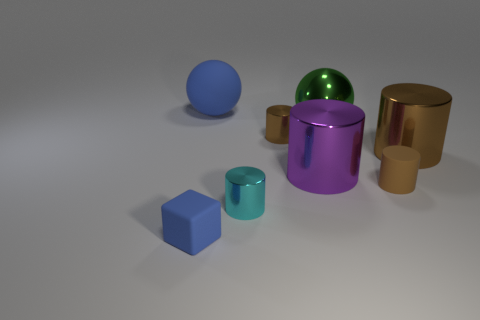Subtract all brown cylinders. How many were subtracted if there are1brown cylinders left? 2 Subtract all yellow cubes. How many brown cylinders are left? 3 Subtract all cyan cylinders. How many cylinders are left? 4 Subtract all matte cylinders. How many cylinders are left? 4 Subtract all cyan cylinders. Subtract all brown cubes. How many cylinders are left? 4 Add 2 tiny brown shiny cylinders. How many objects exist? 10 Subtract all cubes. How many objects are left? 7 Add 8 red metallic cylinders. How many red metallic cylinders exist? 8 Subtract 0 purple balls. How many objects are left? 8 Subtract all brown cubes. Subtract all rubber things. How many objects are left? 5 